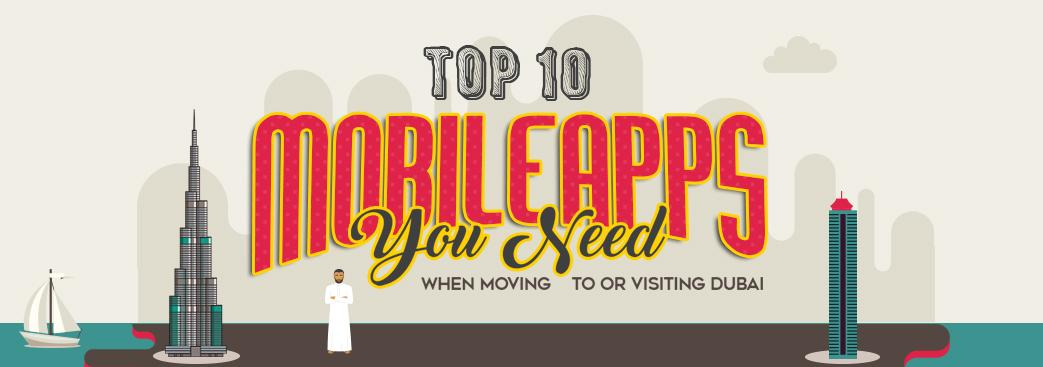Indicate a few pertinent items in this graphic. The man in the picture is wearing a thawb, not a suit. The tallest building, either Burj Khalifa or Burj Al Arab, is Burj Khalifa. 